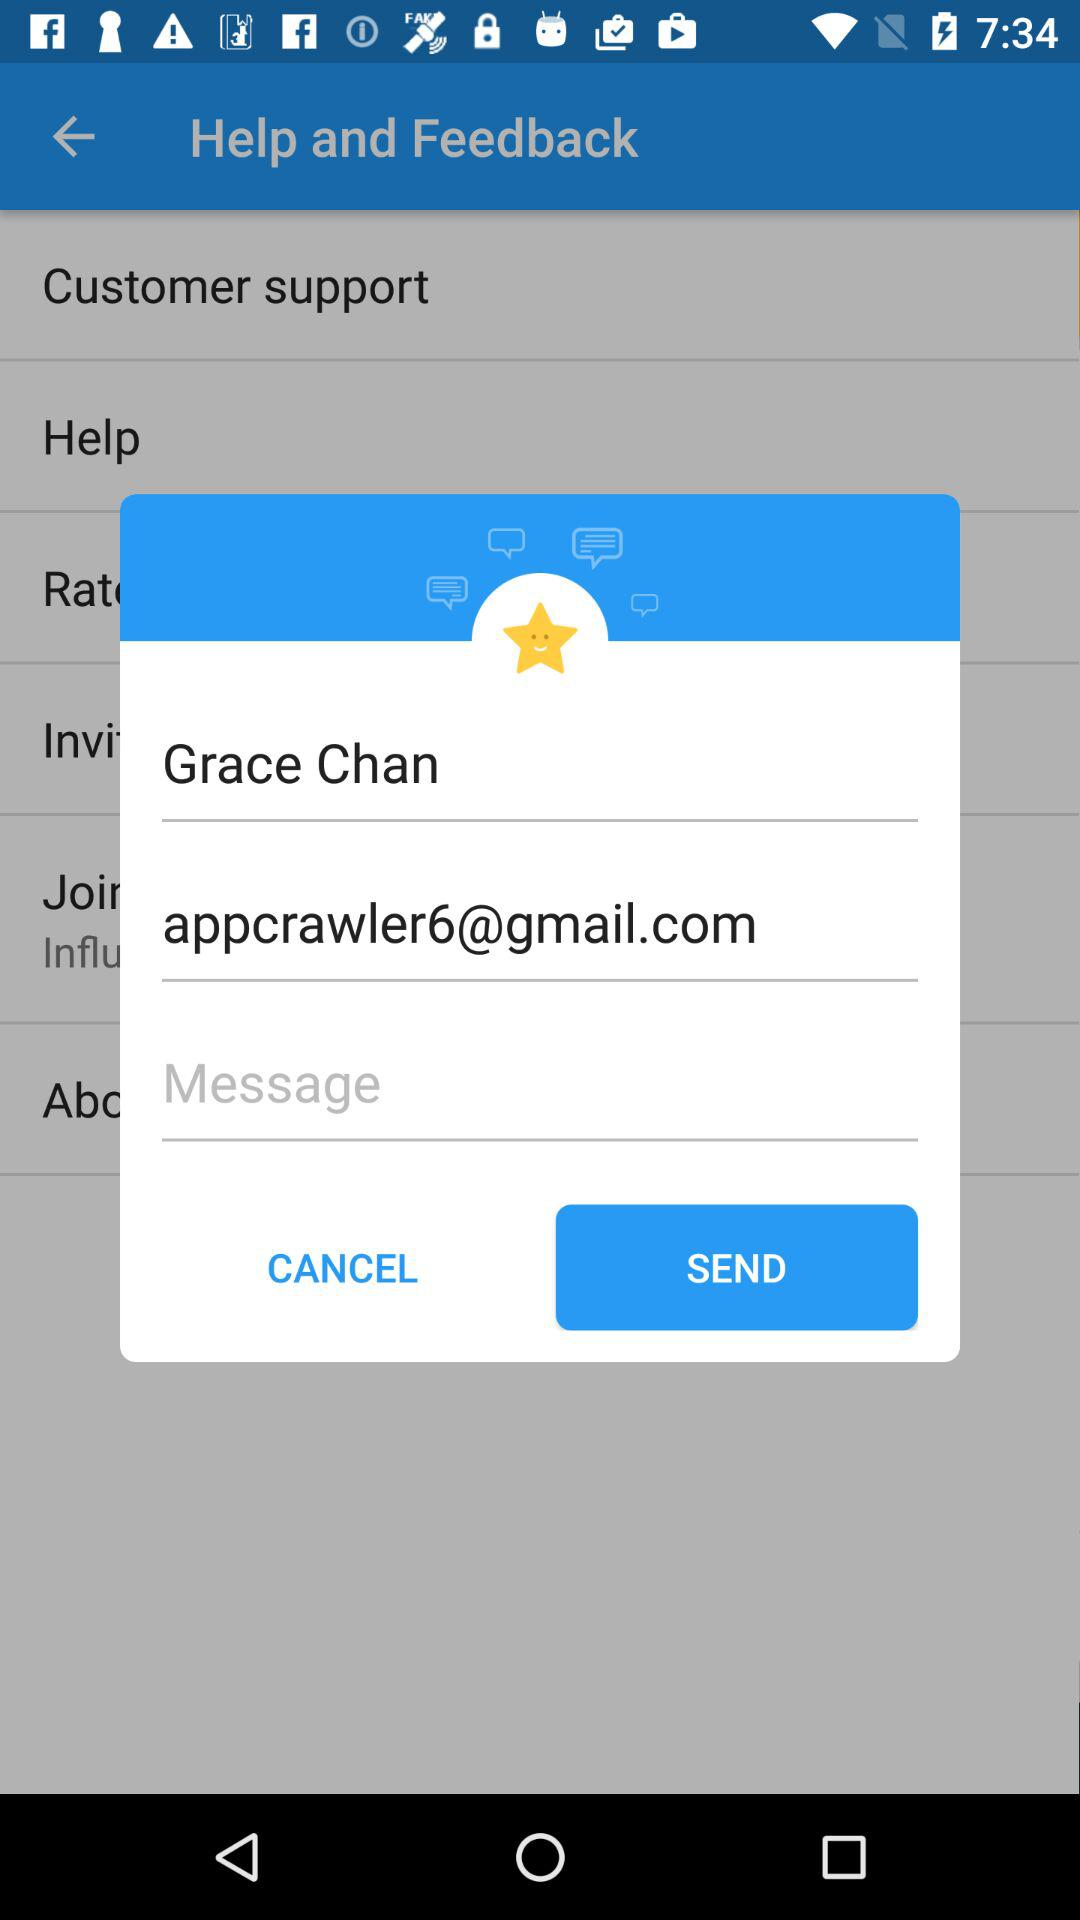What is the user name? The user name is Grace Chan. 